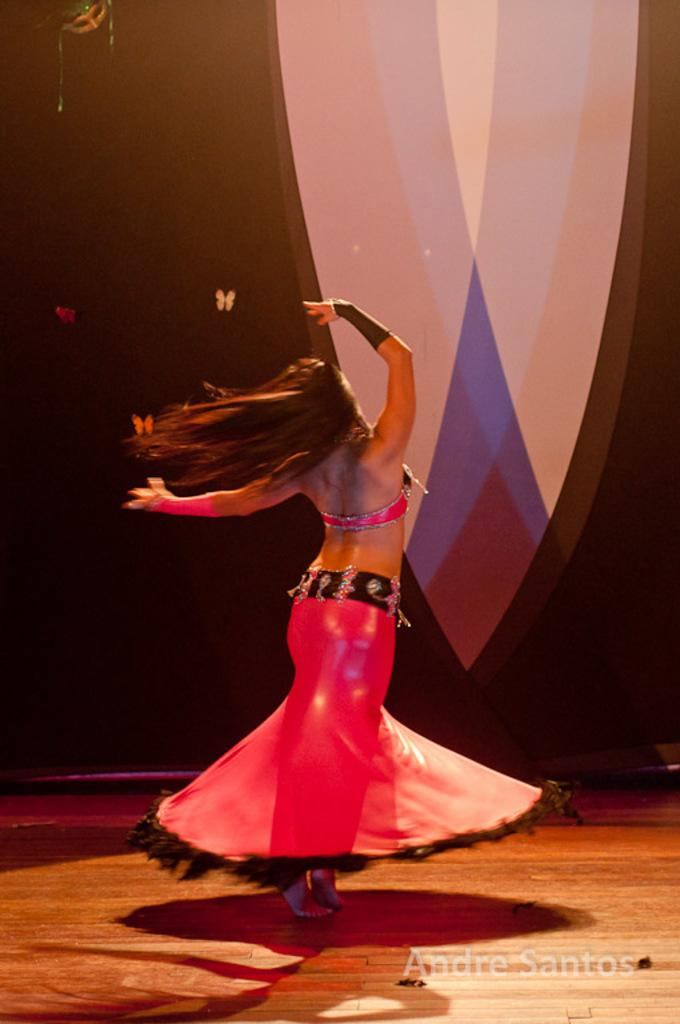What is the woman in the image wearing? The woman is wearing a pink dress. What is the color of the woman's hair in the image? The woman has long hair. Where is the woman standing in the image? The woman is standing on the floor. What can be seen in the background of the image? There are butterflies and a mask in the background of the image. What type of cup can be seen on the farm in the image? There is no cup or farm present in the image; it features a woman with long hair wearing a pink dress and standing on the floor, with butterflies and a mask in the background. 